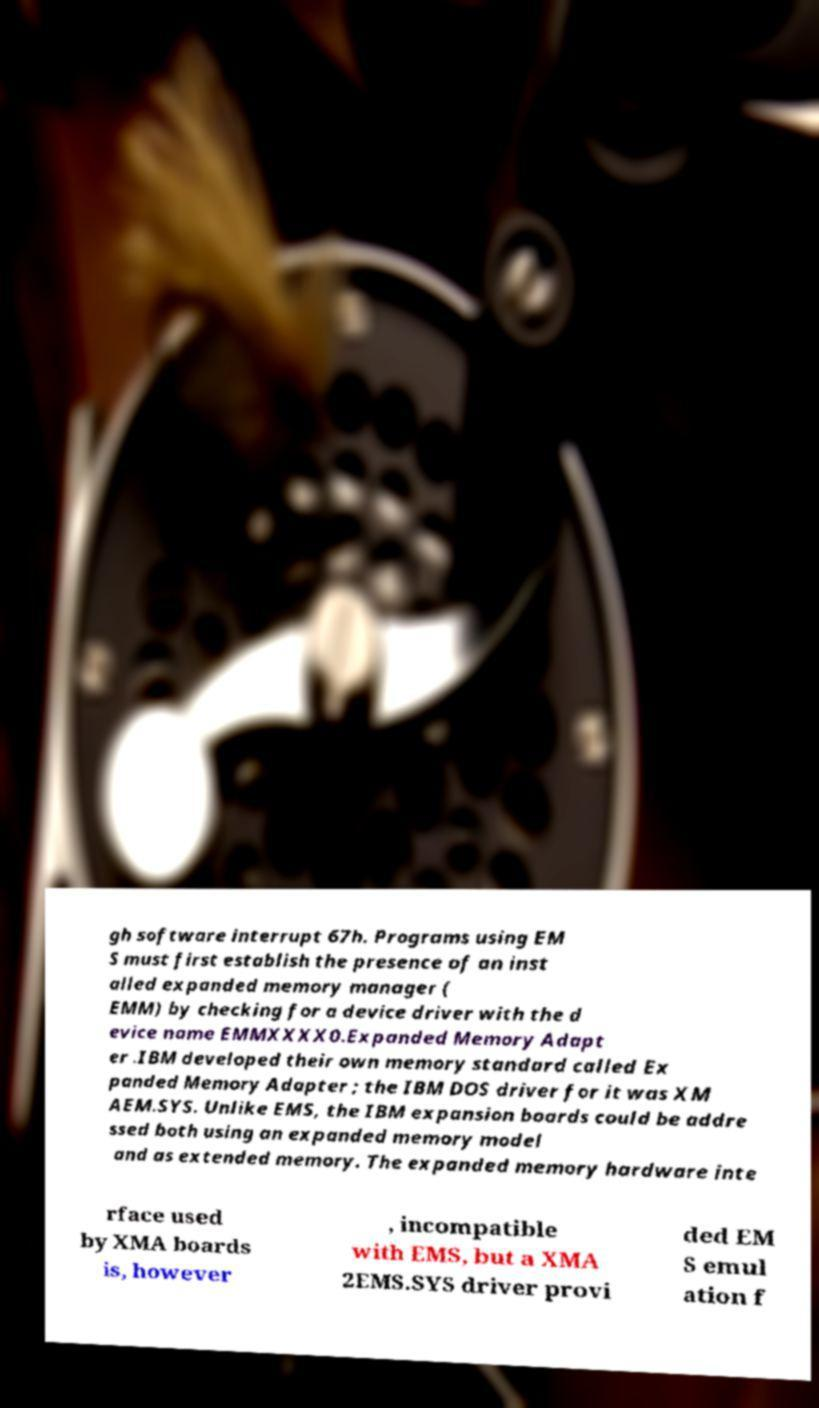Could you extract and type out the text from this image? gh software interrupt 67h. Programs using EM S must first establish the presence of an inst alled expanded memory manager ( EMM) by checking for a device driver with the d evice name EMMXXXX0.Expanded Memory Adapt er .IBM developed their own memory standard called Ex panded Memory Adapter ; the IBM DOS driver for it was XM AEM.SYS. Unlike EMS, the IBM expansion boards could be addre ssed both using an expanded memory model and as extended memory. The expanded memory hardware inte rface used by XMA boards is, however , incompatible with EMS, but a XMA 2EMS.SYS driver provi ded EM S emul ation f 